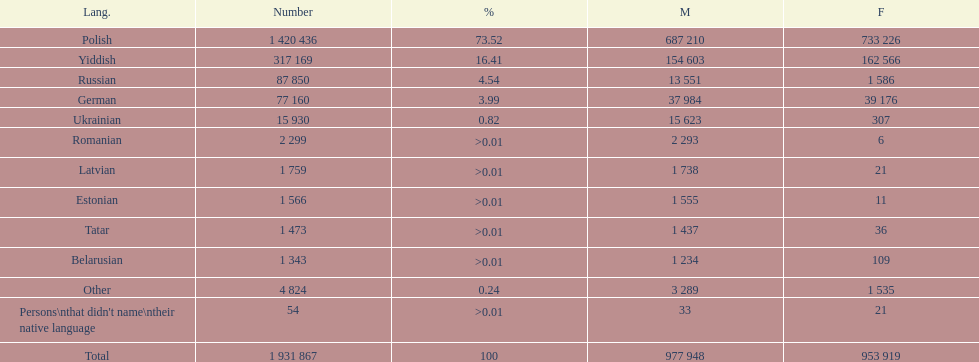Which languages are spoken by more than 50,000 people? Polish, Yiddish, Russian, German. Of these languages, which ones are spoken by less than 15% of the population? Russian, German. Of the remaining two, which one is spoken by 37,984 males? German. 